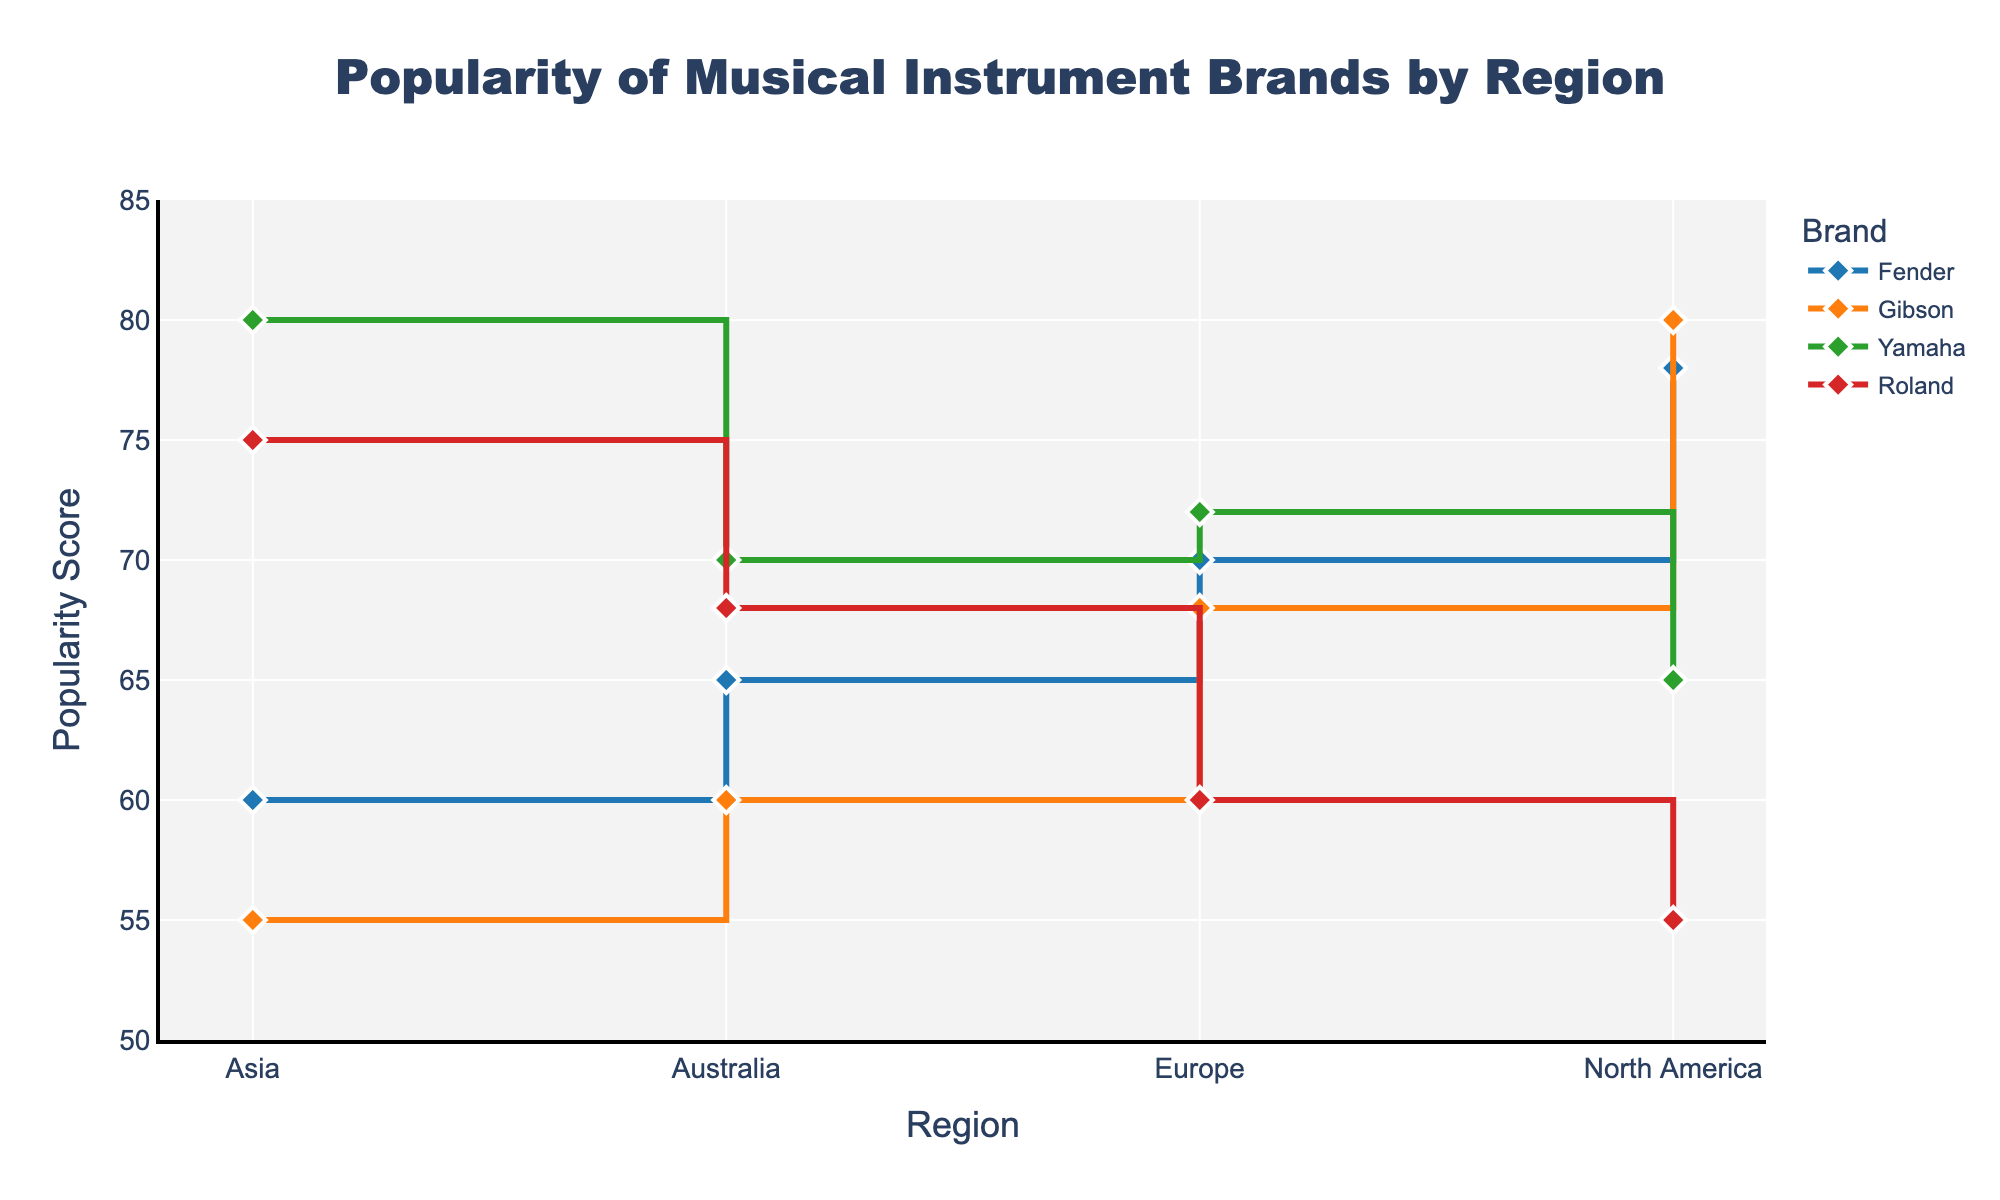What is the title of the plot? The plot's title is located at the top and reads, "Popularity of Musical Instrument Brands by Region."
Answer: Popularity of Musical Instrument Brands by Region Which brand has the highest popularity score in North America? Look for the tallest point in the North America section. Gibson has the highest score with a popularity of 80.
Answer: Gibson What is the popularity score of Yamaha in Asia? Locate Yamaha's line and find the point corresponding to the Asia region. The popularity score is 80.
Answer: 80 Which region shows the highest popularity score for Roland? To find Roland's highest score, look at each region's point for Roland. Asia has the highest score at 75.
Answer: Asia How does Fender's popularity in North America compare to its popularity in Europe? Compare the points for Fender in North America and Europe. North America's score is 78, while Europe's is 70.
Answer: Fender is more popular in North America What is the average popularity score of Gibson across all regions? Add Gibson's popularity scores across all regions (80 + 68 + 55 + 60) and divide by the number of regions (4). The average is (80 + 68 + 55 + 60) / 4 = 65.75.
Answer: 65.75 Between Europe and Australia, which region has a higher average popularity score of all brands? Calculate the average for each region. 
For Europe: (70 + 68 + 72 + 60) / 4 = 67.5.
For Australia: (65 + 60 + 70 + 68) / 4 = 65.75.
Europe's average is slightly higher than Australia's.
Answer: Europe Which brand has the most significant difference in popularity scores between any two regions? Look for the largest vertical distance between two regions for each brand. Yamaha has the most significant difference between Asia (80) and North America (65), a difference of 15.
Answer: Yamaha How do Yamaha and Roland's popularity scores compare in the Asia region? Locate both Yamaha and Roland's scores for the Asia region. Yamaha has a score of 80, and Roland has a score of 75.
Answer: Yamaha is more popular than Roland in Asia What is the median popularity score of Fender across all regions? List Fender's scores (78, 70, 60, 65) and find the middle value. Since there are four data points, the median is the average of the two middle values (65 and 70). (65 + 70) / 2 = 67.5.
Answer: 67.5 